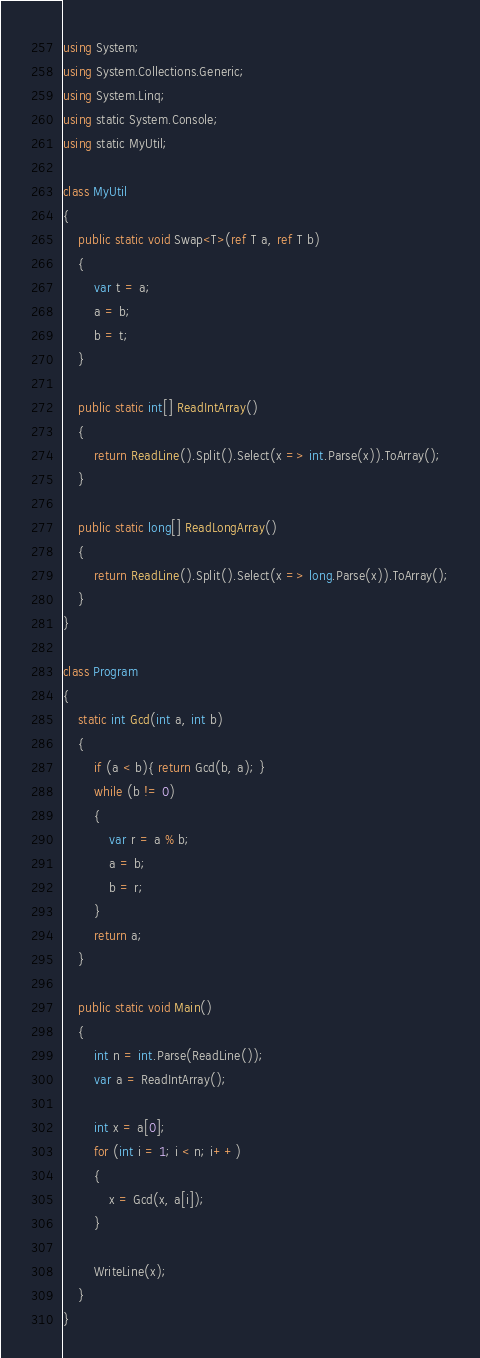<code> <loc_0><loc_0><loc_500><loc_500><_C#_>using System;
using System.Collections.Generic;
using System.Linq;
using static System.Console;
using static MyUtil;

class MyUtil
{
    public static void Swap<T>(ref T a, ref T b)
    {
        var t = a;
        a = b;
        b = t;
    }

    public static int[] ReadIntArray()
    {
        return ReadLine().Split().Select(x => int.Parse(x)).ToArray();
    }

    public static long[] ReadLongArray()
    {
        return ReadLine().Split().Select(x => long.Parse(x)).ToArray();
    }
}

class Program
{
    static int Gcd(int a, int b)
    {
        if (a < b){ return Gcd(b, a); }
        while (b != 0)
        {
            var r = a % b;
            a = b;
            b = r;
        }
        return a;
    }

    public static void Main()
    {
        int n = int.Parse(ReadLine());
        var a = ReadIntArray();

        int x = a[0];
        for (int i = 1; i < n; i++)
        {
            x = Gcd(x, a[i]);
        }

        WriteLine(x);
    }
}
</code> 